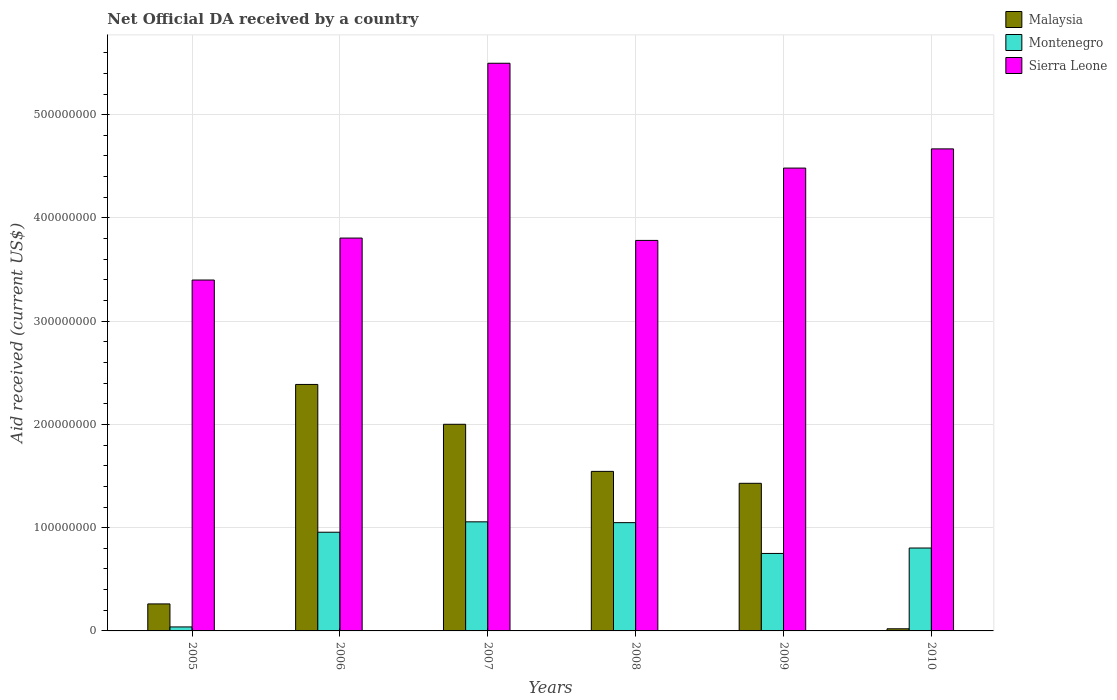How many groups of bars are there?
Your answer should be very brief. 6. Are the number of bars per tick equal to the number of legend labels?
Give a very brief answer. Yes. Are the number of bars on each tick of the X-axis equal?
Ensure brevity in your answer.  Yes. What is the label of the 6th group of bars from the left?
Give a very brief answer. 2010. In how many cases, is the number of bars for a given year not equal to the number of legend labels?
Ensure brevity in your answer.  0. What is the net official development assistance aid received in Montenegro in 2008?
Provide a succinct answer. 1.05e+08. Across all years, what is the maximum net official development assistance aid received in Malaysia?
Provide a succinct answer. 2.39e+08. Across all years, what is the minimum net official development assistance aid received in Montenegro?
Make the answer very short. 3.86e+06. In which year was the net official development assistance aid received in Sierra Leone maximum?
Your answer should be very brief. 2007. What is the total net official development assistance aid received in Montenegro in the graph?
Your answer should be very brief. 4.65e+08. What is the difference between the net official development assistance aid received in Sierra Leone in 2007 and that in 2010?
Make the answer very short. 8.29e+07. What is the difference between the net official development assistance aid received in Montenegro in 2008 and the net official development assistance aid received in Sierra Leone in 2007?
Offer a very short reply. -4.45e+08. What is the average net official development assistance aid received in Montenegro per year?
Give a very brief answer. 7.75e+07. In the year 2010, what is the difference between the net official development assistance aid received in Sierra Leone and net official development assistance aid received in Malaysia?
Your answer should be very brief. 4.65e+08. In how many years, is the net official development assistance aid received in Montenegro greater than 320000000 US$?
Make the answer very short. 0. What is the ratio of the net official development assistance aid received in Sierra Leone in 2005 to that in 2007?
Offer a very short reply. 0.62. What is the difference between the highest and the second highest net official development assistance aid received in Montenegro?
Keep it short and to the point. 7.90e+05. What is the difference between the highest and the lowest net official development assistance aid received in Malaysia?
Your response must be concise. 2.37e+08. In how many years, is the net official development assistance aid received in Malaysia greater than the average net official development assistance aid received in Malaysia taken over all years?
Your answer should be compact. 4. Is the sum of the net official development assistance aid received in Malaysia in 2005 and 2007 greater than the maximum net official development assistance aid received in Montenegro across all years?
Provide a succinct answer. Yes. What does the 3rd bar from the left in 2006 represents?
Offer a terse response. Sierra Leone. What does the 3rd bar from the right in 2009 represents?
Provide a short and direct response. Malaysia. Is it the case that in every year, the sum of the net official development assistance aid received in Montenegro and net official development assistance aid received in Malaysia is greater than the net official development assistance aid received in Sierra Leone?
Offer a very short reply. No. How many years are there in the graph?
Make the answer very short. 6. Are the values on the major ticks of Y-axis written in scientific E-notation?
Offer a very short reply. No. Where does the legend appear in the graph?
Keep it short and to the point. Top right. What is the title of the graph?
Your answer should be very brief. Net Official DA received by a country. Does "Moldova" appear as one of the legend labels in the graph?
Make the answer very short. No. What is the label or title of the X-axis?
Offer a terse response. Years. What is the label or title of the Y-axis?
Your answer should be compact. Aid received (current US$). What is the Aid received (current US$) in Malaysia in 2005?
Your response must be concise. 2.62e+07. What is the Aid received (current US$) in Montenegro in 2005?
Make the answer very short. 3.86e+06. What is the Aid received (current US$) in Sierra Leone in 2005?
Your answer should be compact. 3.40e+08. What is the Aid received (current US$) in Malaysia in 2006?
Provide a short and direct response. 2.39e+08. What is the Aid received (current US$) in Montenegro in 2006?
Your answer should be compact. 9.56e+07. What is the Aid received (current US$) of Sierra Leone in 2006?
Provide a short and direct response. 3.80e+08. What is the Aid received (current US$) in Malaysia in 2007?
Make the answer very short. 2.00e+08. What is the Aid received (current US$) in Montenegro in 2007?
Your response must be concise. 1.06e+08. What is the Aid received (current US$) in Sierra Leone in 2007?
Offer a terse response. 5.50e+08. What is the Aid received (current US$) of Malaysia in 2008?
Your answer should be very brief. 1.55e+08. What is the Aid received (current US$) of Montenegro in 2008?
Give a very brief answer. 1.05e+08. What is the Aid received (current US$) of Sierra Leone in 2008?
Your answer should be very brief. 3.78e+08. What is the Aid received (current US$) in Malaysia in 2009?
Give a very brief answer. 1.43e+08. What is the Aid received (current US$) in Montenegro in 2009?
Give a very brief answer. 7.50e+07. What is the Aid received (current US$) of Sierra Leone in 2009?
Keep it short and to the point. 4.48e+08. What is the Aid received (current US$) in Malaysia in 2010?
Give a very brief answer. 2.06e+06. What is the Aid received (current US$) of Montenegro in 2010?
Your response must be concise. 8.03e+07. What is the Aid received (current US$) in Sierra Leone in 2010?
Provide a succinct answer. 4.67e+08. Across all years, what is the maximum Aid received (current US$) in Malaysia?
Make the answer very short. 2.39e+08. Across all years, what is the maximum Aid received (current US$) in Montenegro?
Your response must be concise. 1.06e+08. Across all years, what is the maximum Aid received (current US$) of Sierra Leone?
Your answer should be compact. 5.50e+08. Across all years, what is the minimum Aid received (current US$) in Malaysia?
Make the answer very short. 2.06e+06. Across all years, what is the minimum Aid received (current US$) of Montenegro?
Give a very brief answer. 3.86e+06. Across all years, what is the minimum Aid received (current US$) of Sierra Leone?
Your response must be concise. 3.40e+08. What is the total Aid received (current US$) of Malaysia in the graph?
Your response must be concise. 7.65e+08. What is the total Aid received (current US$) of Montenegro in the graph?
Your answer should be compact. 4.65e+08. What is the total Aid received (current US$) in Sierra Leone in the graph?
Offer a very short reply. 2.56e+09. What is the difference between the Aid received (current US$) of Malaysia in 2005 and that in 2006?
Provide a short and direct response. -2.13e+08. What is the difference between the Aid received (current US$) in Montenegro in 2005 and that in 2006?
Give a very brief answer. -9.17e+07. What is the difference between the Aid received (current US$) in Sierra Leone in 2005 and that in 2006?
Offer a very short reply. -4.06e+07. What is the difference between the Aid received (current US$) of Malaysia in 2005 and that in 2007?
Ensure brevity in your answer.  -1.74e+08. What is the difference between the Aid received (current US$) in Montenegro in 2005 and that in 2007?
Offer a very short reply. -1.02e+08. What is the difference between the Aid received (current US$) of Sierra Leone in 2005 and that in 2007?
Make the answer very short. -2.10e+08. What is the difference between the Aid received (current US$) in Malaysia in 2005 and that in 2008?
Make the answer very short. -1.28e+08. What is the difference between the Aid received (current US$) in Montenegro in 2005 and that in 2008?
Make the answer very short. -1.01e+08. What is the difference between the Aid received (current US$) in Sierra Leone in 2005 and that in 2008?
Provide a succinct answer. -3.84e+07. What is the difference between the Aid received (current US$) of Malaysia in 2005 and that in 2009?
Your answer should be very brief. -1.17e+08. What is the difference between the Aid received (current US$) of Montenegro in 2005 and that in 2009?
Offer a very short reply. -7.12e+07. What is the difference between the Aid received (current US$) in Sierra Leone in 2005 and that in 2009?
Provide a short and direct response. -1.08e+08. What is the difference between the Aid received (current US$) of Malaysia in 2005 and that in 2010?
Keep it short and to the point. 2.41e+07. What is the difference between the Aid received (current US$) in Montenegro in 2005 and that in 2010?
Your answer should be compact. -7.64e+07. What is the difference between the Aid received (current US$) in Sierra Leone in 2005 and that in 2010?
Provide a succinct answer. -1.27e+08. What is the difference between the Aid received (current US$) in Malaysia in 2006 and that in 2007?
Provide a short and direct response. 3.86e+07. What is the difference between the Aid received (current US$) in Montenegro in 2006 and that in 2007?
Make the answer very short. -1.01e+07. What is the difference between the Aid received (current US$) of Sierra Leone in 2006 and that in 2007?
Provide a succinct answer. -1.69e+08. What is the difference between the Aid received (current US$) of Malaysia in 2006 and that in 2008?
Your answer should be very brief. 8.42e+07. What is the difference between the Aid received (current US$) in Montenegro in 2006 and that in 2008?
Ensure brevity in your answer.  -9.27e+06. What is the difference between the Aid received (current US$) of Sierra Leone in 2006 and that in 2008?
Your answer should be compact. 2.26e+06. What is the difference between the Aid received (current US$) of Malaysia in 2006 and that in 2009?
Provide a succinct answer. 9.58e+07. What is the difference between the Aid received (current US$) in Montenegro in 2006 and that in 2009?
Give a very brief answer. 2.06e+07. What is the difference between the Aid received (current US$) in Sierra Leone in 2006 and that in 2009?
Make the answer very short. -6.78e+07. What is the difference between the Aid received (current US$) in Malaysia in 2006 and that in 2010?
Ensure brevity in your answer.  2.37e+08. What is the difference between the Aid received (current US$) of Montenegro in 2006 and that in 2010?
Give a very brief answer. 1.53e+07. What is the difference between the Aid received (current US$) of Sierra Leone in 2006 and that in 2010?
Your answer should be compact. -8.64e+07. What is the difference between the Aid received (current US$) in Malaysia in 2007 and that in 2008?
Your answer should be very brief. 4.56e+07. What is the difference between the Aid received (current US$) of Montenegro in 2007 and that in 2008?
Your response must be concise. 7.90e+05. What is the difference between the Aid received (current US$) of Sierra Leone in 2007 and that in 2008?
Offer a terse response. 1.72e+08. What is the difference between the Aid received (current US$) in Malaysia in 2007 and that in 2009?
Your response must be concise. 5.72e+07. What is the difference between the Aid received (current US$) in Montenegro in 2007 and that in 2009?
Offer a terse response. 3.06e+07. What is the difference between the Aid received (current US$) of Sierra Leone in 2007 and that in 2009?
Keep it short and to the point. 1.02e+08. What is the difference between the Aid received (current US$) in Malaysia in 2007 and that in 2010?
Provide a succinct answer. 1.98e+08. What is the difference between the Aid received (current US$) of Montenegro in 2007 and that in 2010?
Provide a short and direct response. 2.54e+07. What is the difference between the Aid received (current US$) in Sierra Leone in 2007 and that in 2010?
Your answer should be compact. 8.29e+07. What is the difference between the Aid received (current US$) of Malaysia in 2008 and that in 2009?
Your response must be concise. 1.16e+07. What is the difference between the Aid received (current US$) of Montenegro in 2008 and that in 2009?
Make the answer very short. 2.98e+07. What is the difference between the Aid received (current US$) in Sierra Leone in 2008 and that in 2009?
Your answer should be compact. -7.00e+07. What is the difference between the Aid received (current US$) in Malaysia in 2008 and that in 2010?
Offer a very short reply. 1.52e+08. What is the difference between the Aid received (current US$) in Montenegro in 2008 and that in 2010?
Provide a short and direct response. 2.46e+07. What is the difference between the Aid received (current US$) of Sierra Leone in 2008 and that in 2010?
Offer a terse response. -8.86e+07. What is the difference between the Aid received (current US$) in Malaysia in 2009 and that in 2010?
Keep it short and to the point. 1.41e+08. What is the difference between the Aid received (current US$) of Montenegro in 2009 and that in 2010?
Make the answer very short. -5.25e+06. What is the difference between the Aid received (current US$) of Sierra Leone in 2009 and that in 2010?
Your response must be concise. -1.86e+07. What is the difference between the Aid received (current US$) of Malaysia in 2005 and the Aid received (current US$) of Montenegro in 2006?
Your answer should be compact. -6.94e+07. What is the difference between the Aid received (current US$) of Malaysia in 2005 and the Aid received (current US$) of Sierra Leone in 2006?
Make the answer very short. -3.54e+08. What is the difference between the Aid received (current US$) in Montenegro in 2005 and the Aid received (current US$) in Sierra Leone in 2006?
Your answer should be compact. -3.77e+08. What is the difference between the Aid received (current US$) of Malaysia in 2005 and the Aid received (current US$) of Montenegro in 2007?
Make the answer very short. -7.95e+07. What is the difference between the Aid received (current US$) in Malaysia in 2005 and the Aid received (current US$) in Sierra Leone in 2007?
Provide a short and direct response. -5.24e+08. What is the difference between the Aid received (current US$) of Montenegro in 2005 and the Aid received (current US$) of Sierra Leone in 2007?
Offer a very short reply. -5.46e+08. What is the difference between the Aid received (current US$) in Malaysia in 2005 and the Aid received (current US$) in Montenegro in 2008?
Your response must be concise. -7.87e+07. What is the difference between the Aid received (current US$) in Malaysia in 2005 and the Aid received (current US$) in Sierra Leone in 2008?
Make the answer very short. -3.52e+08. What is the difference between the Aid received (current US$) of Montenegro in 2005 and the Aid received (current US$) of Sierra Leone in 2008?
Ensure brevity in your answer.  -3.74e+08. What is the difference between the Aid received (current US$) in Malaysia in 2005 and the Aid received (current US$) in Montenegro in 2009?
Ensure brevity in your answer.  -4.89e+07. What is the difference between the Aid received (current US$) in Malaysia in 2005 and the Aid received (current US$) in Sierra Leone in 2009?
Provide a succinct answer. -4.22e+08. What is the difference between the Aid received (current US$) in Montenegro in 2005 and the Aid received (current US$) in Sierra Leone in 2009?
Your response must be concise. -4.44e+08. What is the difference between the Aid received (current US$) in Malaysia in 2005 and the Aid received (current US$) in Montenegro in 2010?
Your response must be concise. -5.41e+07. What is the difference between the Aid received (current US$) in Malaysia in 2005 and the Aid received (current US$) in Sierra Leone in 2010?
Make the answer very short. -4.41e+08. What is the difference between the Aid received (current US$) of Montenegro in 2005 and the Aid received (current US$) of Sierra Leone in 2010?
Keep it short and to the point. -4.63e+08. What is the difference between the Aid received (current US$) of Malaysia in 2006 and the Aid received (current US$) of Montenegro in 2007?
Your answer should be compact. 1.33e+08. What is the difference between the Aid received (current US$) of Malaysia in 2006 and the Aid received (current US$) of Sierra Leone in 2007?
Your answer should be very brief. -3.11e+08. What is the difference between the Aid received (current US$) of Montenegro in 2006 and the Aid received (current US$) of Sierra Leone in 2007?
Keep it short and to the point. -4.54e+08. What is the difference between the Aid received (current US$) in Malaysia in 2006 and the Aid received (current US$) in Montenegro in 2008?
Your answer should be very brief. 1.34e+08. What is the difference between the Aid received (current US$) in Malaysia in 2006 and the Aid received (current US$) in Sierra Leone in 2008?
Ensure brevity in your answer.  -1.40e+08. What is the difference between the Aid received (current US$) of Montenegro in 2006 and the Aid received (current US$) of Sierra Leone in 2008?
Provide a succinct answer. -2.83e+08. What is the difference between the Aid received (current US$) in Malaysia in 2006 and the Aid received (current US$) in Montenegro in 2009?
Make the answer very short. 1.64e+08. What is the difference between the Aid received (current US$) of Malaysia in 2006 and the Aid received (current US$) of Sierra Leone in 2009?
Provide a short and direct response. -2.10e+08. What is the difference between the Aid received (current US$) of Montenegro in 2006 and the Aid received (current US$) of Sierra Leone in 2009?
Your answer should be compact. -3.53e+08. What is the difference between the Aid received (current US$) of Malaysia in 2006 and the Aid received (current US$) of Montenegro in 2010?
Provide a short and direct response. 1.58e+08. What is the difference between the Aid received (current US$) of Malaysia in 2006 and the Aid received (current US$) of Sierra Leone in 2010?
Your answer should be compact. -2.28e+08. What is the difference between the Aid received (current US$) of Montenegro in 2006 and the Aid received (current US$) of Sierra Leone in 2010?
Ensure brevity in your answer.  -3.71e+08. What is the difference between the Aid received (current US$) in Malaysia in 2007 and the Aid received (current US$) in Montenegro in 2008?
Ensure brevity in your answer.  9.53e+07. What is the difference between the Aid received (current US$) of Malaysia in 2007 and the Aid received (current US$) of Sierra Leone in 2008?
Make the answer very short. -1.78e+08. What is the difference between the Aid received (current US$) of Montenegro in 2007 and the Aid received (current US$) of Sierra Leone in 2008?
Keep it short and to the point. -2.73e+08. What is the difference between the Aid received (current US$) of Malaysia in 2007 and the Aid received (current US$) of Montenegro in 2009?
Keep it short and to the point. 1.25e+08. What is the difference between the Aid received (current US$) of Malaysia in 2007 and the Aid received (current US$) of Sierra Leone in 2009?
Keep it short and to the point. -2.48e+08. What is the difference between the Aid received (current US$) in Montenegro in 2007 and the Aid received (current US$) in Sierra Leone in 2009?
Provide a short and direct response. -3.43e+08. What is the difference between the Aid received (current US$) of Malaysia in 2007 and the Aid received (current US$) of Montenegro in 2010?
Provide a short and direct response. 1.20e+08. What is the difference between the Aid received (current US$) in Malaysia in 2007 and the Aid received (current US$) in Sierra Leone in 2010?
Offer a very short reply. -2.67e+08. What is the difference between the Aid received (current US$) of Montenegro in 2007 and the Aid received (current US$) of Sierra Leone in 2010?
Your answer should be compact. -3.61e+08. What is the difference between the Aid received (current US$) of Malaysia in 2008 and the Aid received (current US$) of Montenegro in 2009?
Offer a terse response. 7.95e+07. What is the difference between the Aid received (current US$) in Malaysia in 2008 and the Aid received (current US$) in Sierra Leone in 2009?
Keep it short and to the point. -2.94e+08. What is the difference between the Aid received (current US$) of Montenegro in 2008 and the Aid received (current US$) of Sierra Leone in 2009?
Your answer should be very brief. -3.43e+08. What is the difference between the Aid received (current US$) of Malaysia in 2008 and the Aid received (current US$) of Montenegro in 2010?
Give a very brief answer. 7.42e+07. What is the difference between the Aid received (current US$) in Malaysia in 2008 and the Aid received (current US$) in Sierra Leone in 2010?
Provide a short and direct response. -3.12e+08. What is the difference between the Aid received (current US$) in Montenegro in 2008 and the Aid received (current US$) in Sierra Leone in 2010?
Ensure brevity in your answer.  -3.62e+08. What is the difference between the Aid received (current US$) of Malaysia in 2009 and the Aid received (current US$) of Montenegro in 2010?
Offer a terse response. 6.27e+07. What is the difference between the Aid received (current US$) in Malaysia in 2009 and the Aid received (current US$) in Sierra Leone in 2010?
Ensure brevity in your answer.  -3.24e+08. What is the difference between the Aid received (current US$) of Montenegro in 2009 and the Aid received (current US$) of Sierra Leone in 2010?
Make the answer very short. -3.92e+08. What is the average Aid received (current US$) in Malaysia per year?
Keep it short and to the point. 1.27e+08. What is the average Aid received (current US$) of Montenegro per year?
Your answer should be very brief. 7.75e+07. What is the average Aid received (current US$) of Sierra Leone per year?
Provide a succinct answer. 4.27e+08. In the year 2005, what is the difference between the Aid received (current US$) in Malaysia and Aid received (current US$) in Montenegro?
Make the answer very short. 2.23e+07. In the year 2005, what is the difference between the Aid received (current US$) of Malaysia and Aid received (current US$) of Sierra Leone?
Give a very brief answer. -3.14e+08. In the year 2005, what is the difference between the Aid received (current US$) of Montenegro and Aid received (current US$) of Sierra Leone?
Offer a terse response. -3.36e+08. In the year 2006, what is the difference between the Aid received (current US$) of Malaysia and Aid received (current US$) of Montenegro?
Your answer should be very brief. 1.43e+08. In the year 2006, what is the difference between the Aid received (current US$) of Malaysia and Aid received (current US$) of Sierra Leone?
Make the answer very short. -1.42e+08. In the year 2006, what is the difference between the Aid received (current US$) in Montenegro and Aid received (current US$) in Sierra Leone?
Your answer should be very brief. -2.85e+08. In the year 2007, what is the difference between the Aid received (current US$) in Malaysia and Aid received (current US$) in Montenegro?
Ensure brevity in your answer.  9.45e+07. In the year 2007, what is the difference between the Aid received (current US$) of Malaysia and Aid received (current US$) of Sierra Leone?
Give a very brief answer. -3.50e+08. In the year 2007, what is the difference between the Aid received (current US$) in Montenegro and Aid received (current US$) in Sierra Leone?
Your answer should be very brief. -4.44e+08. In the year 2008, what is the difference between the Aid received (current US$) in Malaysia and Aid received (current US$) in Montenegro?
Give a very brief answer. 4.96e+07. In the year 2008, what is the difference between the Aid received (current US$) in Malaysia and Aid received (current US$) in Sierra Leone?
Keep it short and to the point. -2.24e+08. In the year 2008, what is the difference between the Aid received (current US$) in Montenegro and Aid received (current US$) in Sierra Leone?
Make the answer very short. -2.73e+08. In the year 2009, what is the difference between the Aid received (current US$) of Malaysia and Aid received (current US$) of Montenegro?
Keep it short and to the point. 6.79e+07. In the year 2009, what is the difference between the Aid received (current US$) in Malaysia and Aid received (current US$) in Sierra Leone?
Offer a terse response. -3.05e+08. In the year 2009, what is the difference between the Aid received (current US$) in Montenegro and Aid received (current US$) in Sierra Leone?
Offer a terse response. -3.73e+08. In the year 2010, what is the difference between the Aid received (current US$) of Malaysia and Aid received (current US$) of Montenegro?
Your answer should be compact. -7.82e+07. In the year 2010, what is the difference between the Aid received (current US$) of Malaysia and Aid received (current US$) of Sierra Leone?
Make the answer very short. -4.65e+08. In the year 2010, what is the difference between the Aid received (current US$) in Montenegro and Aid received (current US$) in Sierra Leone?
Your answer should be very brief. -3.87e+08. What is the ratio of the Aid received (current US$) of Malaysia in 2005 to that in 2006?
Provide a short and direct response. 0.11. What is the ratio of the Aid received (current US$) of Montenegro in 2005 to that in 2006?
Provide a short and direct response. 0.04. What is the ratio of the Aid received (current US$) in Sierra Leone in 2005 to that in 2006?
Your answer should be compact. 0.89. What is the ratio of the Aid received (current US$) of Malaysia in 2005 to that in 2007?
Provide a succinct answer. 0.13. What is the ratio of the Aid received (current US$) of Montenegro in 2005 to that in 2007?
Offer a terse response. 0.04. What is the ratio of the Aid received (current US$) in Sierra Leone in 2005 to that in 2007?
Your response must be concise. 0.62. What is the ratio of the Aid received (current US$) of Malaysia in 2005 to that in 2008?
Your response must be concise. 0.17. What is the ratio of the Aid received (current US$) of Montenegro in 2005 to that in 2008?
Your response must be concise. 0.04. What is the ratio of the Aid received (current US$) of Sierra Leone in 2005 to that in 2008?
Ensure brevity in your answer.  0.9. What is the ratio of the Aid received (current US$) of Malaysia in 2005 to that in 2009?
Offer a terse response. 0.18. What is the ratio of the Aid received (current US$) of Montenegro in 2005 to that in 2009?
Make the answer very short. 0.05. What is the ratio of the Aid received (current US$) in Sierra Leone in 2005 to that in 2009?
Offer a terse response. 0.76. What is the ratio of the Aid received (current US$) of Malaysia in 2005 to that in 2010?
Make the answer very short. 12.69. What is the ratio of the Aid received (current US$) of Montenegro in 2005 to that in 2010?
Your answer should be very brief. 0.05. What is the ratio of the Aid received (current US$) in Sierra Leone in 2005 to that in 2010?
Give a very brief answer. 0.73. What is the ratio of the Aid received (current US$) of Malaysia in 2006 to that in 2007?
Give a very brief answer. 1.19. What is the ratio of the Aid received (current US$) in Montenegro in 2006 to that in 2007?
Offer a very short reply. 0.9. What is the ratio of the Aid received (current US$) of Sierra Leone in 2006 to that in 2007?
Provide a short and direct response. 0.69. What is the ratio of the Aid received (current US$) in Malaysia in 2006 to that in 2008?
Give a very brief answer. 1.54. What is the ratio of the Aid received (current US$) in Montenegro in 2006 to that in 2008?
Keep it short and to the point. 0.91. What is the ratio of the Aid received (current US$) in Sierra Leone in 2006 to that in 2008?
Your answer should be compact. 1.01. What is the ratio of the Aid received (current US$) in Malaysia in 2006 to that in 2009?
Your answer should be very brief. 1.67. What is the ratio of the Aid received (current US$) of Montenegro in 2006 to that in 2009?
Offer a terse response. 1.27. What is the ratio of the Aid received (current US$) in Sierra Leone in 2006 to that in 2009?
Provide a short and direct response. 0.85. What is the ratio of the Aid received (current US$) in Malaysia in 2006 to that in 2010?
Offer a very short reply. 115.88. What is the ratio of the Aid received (current US$) in Montenegro in 2006 to that in 2010?
Ensure brevity in your answer.  1.19. What is the ratio of the Aid received (current US$) of Sierra Leone in 2006 to that in 2010?
Provide a succinct answer. 0.81. What is the ratio of the Aid received (current US$) of Malaysia in 2007 to that in 2008?
Your answer should be very brief. 1.3. What is the ratio of the Aid received (current US$) of Montenegro in 2007 to that in 2008?
Provide a succinct answer. 1.01. What is the ratio of the Aid received (current US$) of Sierra Leone in 2007 to that in 2008?
Make the answer very short. 1.45. What is the ratio of the Aid received (current US$) of Malaysia in 2007 to that in 2009?
Ensure brevity in your answer.  1.4. What is the ratio of the Aid received (current US$) of Montenegro in 2007 to that in 2009?
Keep it short and to the point. 1.41. What is the ratio of the Aid received (current US$) of Sierra Leone in 2007 to that in 2009?
Offer a terse response. 1.23. What is the ratio of the Aid received (current US$) in Malaysia in 2007 to that in 2010?
Keep it short and to the point. 97.15. What is the ratio of the Aid received (current US$) in Montenegro in 2007 to that in 2010?
Your response must be concise. 1.32. What is the ratio of the Aid received (current US$) in Sierra Leone in 2007 to that in 2010?
Your answer should be compact. 1.18. What is the ratio of the Aid received (current US$) in Malaysia in 2008 to that in 2009?
Your answer should be very brief. 1.08. What is the ratio of the Aid received (current US$) in Montenegro in 2008 to that in 2009?
Offer a terse response. 1.4. What is the ratio of the Aid received (current US$) of Sierra Leone in 2008 to that in 2009?
Keep it short and to the point. 0.84. What is the ratio of the Aid received (current US$) in Malaysia in 2008 to that in 2010?
Make the answer very short. 75. What is the ratio of the Aid received (current US$) in Montenegro in 2008 to that in 2010?
Ensure brevity in your answer.  1.31. What is the ratio of the Aid received (current US$) of Sierra Leone in 2008 to that in 2010?
Keep it short and to the point. 0.81. What is the ratio of the Aid received (current US$) in Malaysia in 2009 to that in 2010?
Your answer should be compact. 69.4. What is the ratio of the Aid received (current US$) of Montenegro in 2009 to that in 2010?
Your answer should be compact. 0.93. What is the ratio of the Aid received (current US$) of Sierra Leone in 2009 to that in 2010?
Your answer should be very brief. 0.96. What is the difference between the highest and the second highest Aid received (current US$) in Malaysia?
Your answer should be very brief. 3.86e+07. What is the difference between the highest and the second highest Aid received (current US$) in Montenegro?
Ensure brevity in your answer.  7.90e+05. What is the difference between the highest and the second highest Aid received (current US$) of Sierra Leone?
Offer a terse response. 8.29e+07. What is the difference between the highest and the lowest Aid received (current US$) of Malaysia?
Keep it short and to the point. 2.37e+08. What is the difference between the highest and the lowest Aid received (current US$) in Montenegro?
Keep it short and to the point. 1.02e+08. What is the difference between the highest and the lowest Aid received (current US$) of Sierra Leone?
Give a very brief answer. 2.10e+08. 